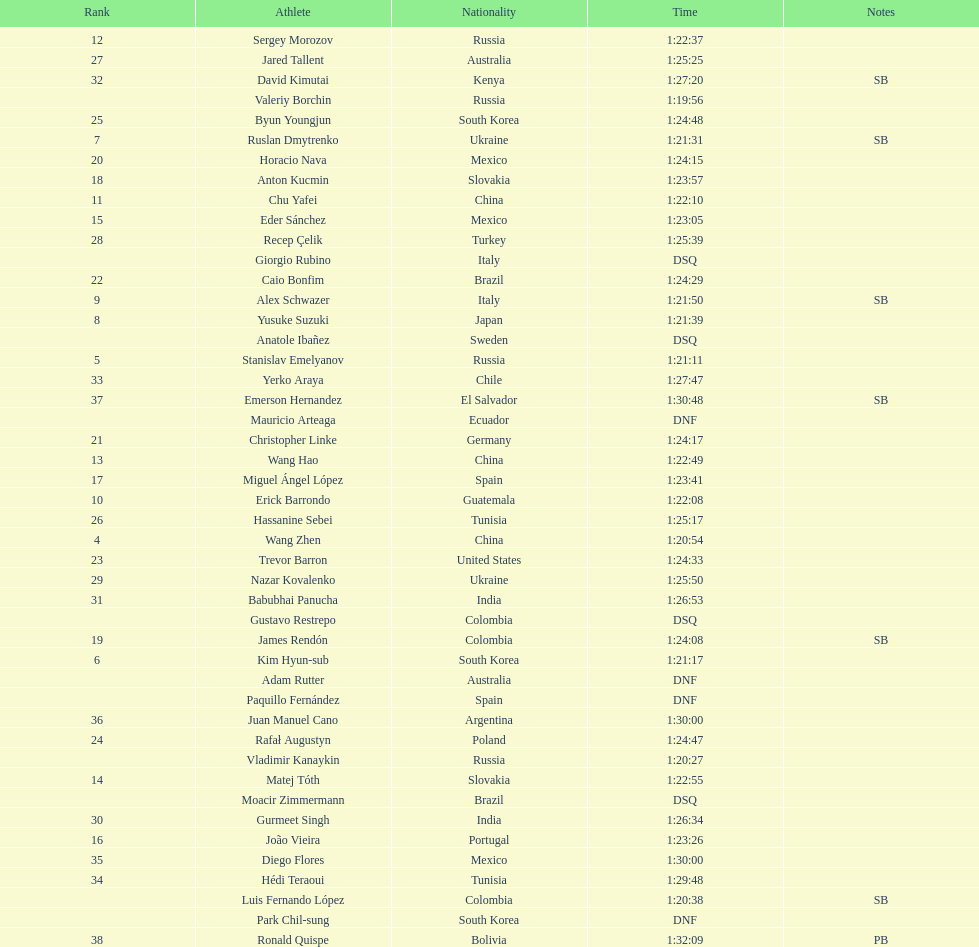Which chinese athlete had the fastest time? Wang Zhen. 